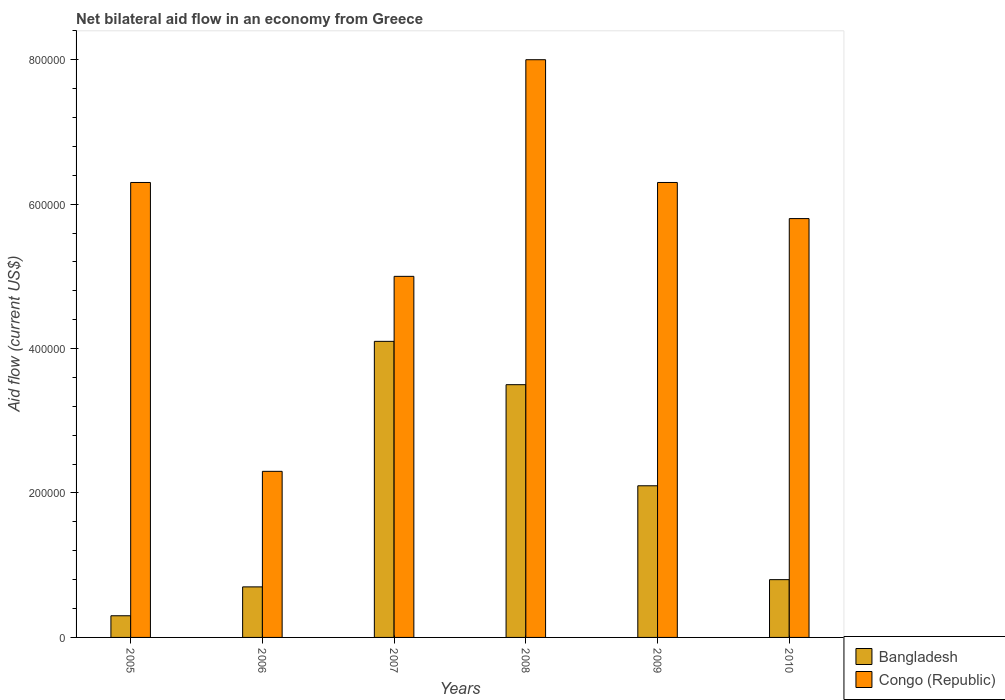How many different coloured bars are there?
Your answer should be very brief. 2. Are the number of bars on each tick of the X-axis equal?
Ensure brevity in your answer.  Yes. How many bars are there on the 6th tick from the right?
Keep it short and to the point. 2. What is the label of the 2nd group of bars from the left?
Your answer should be compact. 2006. What is the net bilateral aid flow in Congo (Republic) in 2009?
Your answer should be compact. 6.30e+05. Across all years, what is the minimum net bilateral aid flow in Congo (Republic)?
Offer a terse response. 2.30e+05. In which year was the net bilateral aid flow in Bangladesh maximum?
Make the answer very short. 2007. What is the total net bilateral aid flow in Congo (Republic) in the graph?
Provide a short and direct response. 3.37e+06. What is the difference between the net bilateral aid flow in Bangladesh in 2005 and that in 2007?
Offer a very short reply. -3.80e+05. What is the average net bilateral aid flow in Bangladesh per year?
Ensure brevity in your answer.  1.92e+05. In the year 2006, what is the difference between the net bilateral aid flow in Congo (Republic) and net bilateral aid flow in Bangladesh?
Your answer should be compact. 1.60e+05. In how many years, is the net bilateral aid flow in Congo (Republic) greater than 480000 US$?
Provide a short and direct response. 5. What is the ratio of the net bilateral aid flow in Congo (Republic) in 2009 to that in 2010?
Give a very brief answer. 1.09. Is the net bilateral aid flow in Bangladesh in 2008 less than that in 2009?
Offer a very short reply. No. Is the difference between the net bilateral aid flow in Congo (Republic) in 2007 and 2009 greater than the difference between the net bilateral aid flow in Bangladesh in 2007 and 2009?
Provide a short and direct response. No. What is the difference between the highest and the second highest net bilateral aid flow in Congo (Republic)?
Offer a very short reply. 1.70e+05. What is the difference between the highest and the lowest net bilateral aid flow in Congo (Republic)?
Your answer should be very brief. 5.70e+05. Is the sum of the net bilateral aid flow in Congo (Republic) in 2008 and 2009 greater than the maximum net bilateral aid flow in Bangladesh across all years?
Your answer should be very brief. Yes. What does the 2nd bar from the left in 2005 represents?
Offer a terse response. Congo (Republic). What does the 1st bar from the right in 2008 represents?
Your answer should be very brief. Congo (Republic). How many bars are there?
Offer a terse response. 12. Are all the bars in the graph horizontal?
Offer a terse response. No. How many years are there in the graph?
Make the answer very short. 6. What is the difference between two consecutive major ticks on the Y-axis?
Your answer should be very brief. 2.00e+05. Where does the legend appear in the graph?
Provide a short and direct response. Bottom right. How many legend labels are there?
Make the answer very short. 2. How are the legend labels stacked?
Ensure brevity in your answer.  Vertical. What is the title of the graph?
Ensure brevity in your answer.  Net bilateral aid flow in an economy from Greece. What is the label or title of the X-axis?
Give a very brief answer. Years. What is the Aid flow (current US$) of Bangladesh in 2005?
Your answer should be compact. 3.00e+04. What is the Aid flow (current US$) in Congo (Republic) in 2005?
Offer a terse response. 6.30e+05. What is the Aid flow (current US$) of Bangladesh in 2006?
Your response must be concise. 7.00e+04. What is the Aid flow (current US$) of Congo (Republic) in 2007?
Your response must be concise. 5.00e+05. What is the Aid flow (current US$) in Bangladesh in 2008?
Make the answer very short. 3.50e+05. What is the Aid flow (current US$) in Congo (Republic) in 2008?
Ensure brevity in your answer.  8.00e+05. What is the Aid flow (current US$) of Bangladesh in 2009?
Provide a succinct answer. 2.10e+05. What is the Aid flow (current US$) of Congo (Republic) in 2009?
Your answer should be very brief. 6.30e+05. What is the Aid flow (current US$) of Congo (Republic) in 2010?
Offer a terse response. 5.80e+05. Across all years, what is the maximum Aid flow (current US$) of Congo (Republic)?
Keep it short and to the point. 8.00e+05. Across all years, what is the minimum Aid flow (current US$) in Bangladesh?
Your response must be concise. 3.00e+04. What is the total Aid flow (current US$) in Bangladesh in the graph?
Offer a terse response. 1.15e+06. What is the total Aid flow (current US$) in Congo (Republic) in the graph?
Provide a short and direct response. 3.37e+06. What is the difference between the Aid flow (current US$) of Bangladesh in 2005 and that in 2006?
Keep it short and to the point. -4.00e+04. What is the difference between the Aid flow (current US$) of Bangladesh in 2005 and that in 2007?
Provide a succinct answer. -3.80e+05. What is the difference between the Aid flow (current US$) in Bangladesh in 2005 and that in 2008?
Provide a succinct answer. -3.20e+05. What is the difference between the Aid flow (current US$) of Congo (Republic) in 2005 and that in 2008?
Your answer should be compact. -1.70e+05. What is the difference between the Aid flow (current US$) in Congo (Republic) in 2005 and that in 2010?
Keep it short and to the point. 5.00e+04. What is the difference between the Aid flow (current US$) in Bangladesh in 2006 and that in 2007?
Ensure brevity in your answer.  -3.40e+05. What is the difference between the Aid flow (current US$) in Bangladesh in 2006 and that in 2008?
Offer a very short reply. -2.80e+05. What is the difference between the Aid flow (current US$) in Congo (Republic) in 2006 and that in 2008?
Give a very brief answer. -5.70e+05. What is the difference between the Aid flow (current US$) of Congo (Republic) in 2006 and that in 2009?
Your response must be concise. -4.00e+05. What is the difference between the Aid flow (current US$) in Bangladesh in 2006 and that in 2010?
Provide a short and direct response. -10000. What is the difference between the Aid flow (current US$) in Congo (Republic) in 2006 and that in 2010?
Your answer should be very brief. -3.50e+05. What is the difference between the Aid flow (current US$) in Congo (Republic) in 2007 and that in 2008?
Make the answer very short. -3.00e+05. What is the difference between the Aid flow (current US$) in Bangladesh in 2007 and that in 2009?
Your response must be concise. 2.00e+05. What is the difference between the Aid flow (current US$) in Congo (Republic) in 2007 and that in 2009?
Your answer should be very brief. -1.30e+05. What is the difference between the Aid flow (current US$) of Congo (Republic) in 2007 and that in 2010?
Offer a terse response. -8.00e+04. What is the difference between the Aid flow (current US$) of Congo (Republic) in 2008 and that in 2009?
Ensure brevity in your answer.  1.70e+05. What is the difference between the Aid flow (current US$) of Congo (Republic) in 2008 and that in 2010?
Ensure brevity in your answer.  2.20e+05. What is the difference between the Aid flow (current US$) in Congo (Republic) in 2009 and that in 2010?
Your response must be concise. 5.00e+04. What is the difference between the Aid flow (current US$) of Bangladesh in 2005 and the Aid flow (current US$) of Congo (Republic) in 2006?
Make the answer very short. -2.00e+05. What is the difference between the Aid flow (current US$) in Bangladesh in 2005 and the Aid flow (current US$) in Congo (Republic) in 2007?
Ensure brevity in your answer.  -4.70e+05. What is the difference between the Aid flow (current US$) in Bangladesh in 2005 and the Aid flow (current US$) in Congo (Republic) in 2008?
Keep it short and to the point. -7.70e+05. What is the difference between the Aid flow (current US$) in Bangladesh in 2005 and the Aid flow (current US$) in Congo (Republic) in 2009?
Your response must be concise. -6.00e+05. What is the difference between the Aid flow (current US$) of Bangladesh in 2005 and the Aid flow (current US$) of Congo (Republic) in 2010?
Offer a terse response. -5.50e+05. What is the difference between the Aid flow (current US$) in Bangladesh in 2006 and the Aid flow (current US$) in Congo (Republic) in 2007?
Give a very brief answer. -4.30e+05. What is the difference between the Aid flow (current US$) of Bangladesh in 2006 and the Aid flow (current US$) of Congo (Republic) in 2008?
Your response must be concise. -7.30e+05. What is the difference between the Aid flow (current US$) of Bangladesh in 2006 and the Aid flow (current US$) of Congo (Republic) in 2009?
Your answer should be very brief. -5.60e+05. What is the difference between the Aid flow (current US$) in Bangladesh in 2006 and the Aid flow (current US$) in Congo (Republic) in 2010?
Your answer should be compact. -5.10e+05. What is the difference between the Aid flow (current US$) in Bangladesh in 2007 and the Aid flow (current US$) in Congo (Republic) in 2008?
Offer a terse response. -3.90e+05. What is the difference between the Aid flow (current US$) in Bangladesh in 2008 and the Aid flow (current US$) in Congo (Republic) in 2009?
Offer a terse response. -2.80e+05. What is the difference between the Aid flow (current US$) in Bangladesh in 2008 and the Aid flow (current US$) in Congo (Republic) in 2010?
Keep it short and to the point. -2.30e+05. What is the difference between the Aid flow (current US$) in Bangladesh in 2009 and the Aid flow (current US$) in Congo (Republic) in 2010?
Keep it short and to the point. -3.70e+05. What is the average Aid flow (current US$) of Bangladesh per year?
Ensure brevity in your answer.  1.92e+05. What is the average Aid flow (current US$) of Congo (Republic) per year?
Ensure brevity in your answer.  5.62e+05. In the year 2005, what is the difference between the Aid flow (current US$) of Bangladesh and Aid flow (current US$) of Congo (Republic)?
Give a very brief answer. -6.00e+05. In the year 2006, what is the difference between the Aid flow (current US$) in Bangladesh and Aid flow (current US$) in Congo (Republic)?
Offer a very short reply. -1.60e+05. In the year 2007, what is the difference between the Aid flow (current US$) in Bangladesh and Aid flow (current US$) in Congo (Republic)?
Make the answer very short. -9.00e+04. In the year 2008, what is the difference between the Aid flow (current US$) in Bangladesh and Aid flow (current US$) in Congo (Republic)?
Ensure brevity in your answer.  -4.50e+05. In the year 2009, what is the difference between the Aid flow (current US$) of Bangladesh and Aid flow (current US$) of Congo (Republic)?
Your answer should be compact. -4.20e+05. In the year 2010, what is the difference between the Aid flow (current US$) of Bangladesh and Aid flow (current US$) of Congo (Republic)?
Keep it short and to the point. -5.00e+05. What is the ratio of the Aid flow (current US$) of Bangladesh in 2005 to that in 2006?
Offer a terse response. 0.43. What is the ratio of the Aid flow (current US$) in Congo (Republic) in 2005 to that in 2006?
Make the answer very short. 2.74. What is the ratio of the Aid flow (current US$) in Bangladesh in 2005 to that in 2007?
Your answer should be very brief. 0.07. What is the ratio of the Aid flow (current US$) in Congo (Republic) in 2005 to that in 2007?
Your response must be concise. 1.26. What is the ratio of the Aid flow (current US$) in Bangladesh in 2005 to that in 2008?
Offer a very short reply. 0.09. What is the ratio of the Aid flow (current US$) in Congo (Republic) in 2005 to that in 2008?
Give a very brief answer. 0.79. What is the ratio of the Aid flow (current US$) in Bangladesh in 2005 to that in 2009?
Offer a very short reply. 0.14. What is the ratio of the Aid flow (current US$) of Congo (Republic) in 2005 to that in 2009?
Offer a terse response. 1. What is the ratio of the Aid flow (current US$) in Congo (Republic) in 2005 to that in 2010?
Ensure brevity in your answer.  1.09. What is the ratio of the Aid flow (current US$) of Bangladesh in 2006 to that in 2007?
Your answer should be compact. 0.17. What is the ratio of the Aid flow (current US$) in Congo (Republic) in 2006 to that in 2007?
Give a very brief answer. 0.46. What is the ratio of the Aid flow (current US$) in Congo (Republic) in 2006 to that in 2008?
Provide a succinct answer. 0.29. What is the ratio of the Aid flow (current US$) of Bangladesh in 2006 to that in 2009?
Provide a short and direct response. 0.33. What is the ratio of the Aid flow (current US$) in Congo (Republic) in 2006 to that in 2009?
Provide a succinct answer. 0.37. What is the ratio of the Aid flow (current US$) in Bangladesh in 2006 to that in 2010?
Ensure brevity in your answer.  0.88. What is the ratio of the Aid flow (current US$) in Congo (Republic) in 2006 to that in 2010?
Keep it short and to the point. 0.4. What is the ratio of the Aid flow (current US$) of Bangladesh in 2007 to that in 2008?
Your response must be concise. 1.17. What is the ratio of the Aid flow (current US$) in Bangladesh in 2007 to that in 2009?
Your answer should be very brief. 1.95. What is the ratio of the Aid flow (current US$) in Congo (Republic) in 2007 to that in 2009?
Give a very brief answer. 0.79. What is the ratio of the Aid flow (current US$) in Bangladesh in 2007 to that in 2010?
Offer a very short reply. 5.12. What is the ratio of the Aid flow (current US$) in Congo (Republic) in 2007 to that in 2010?
Offer a very short reply. 0.86. What is the ratio of the Aid flow (current US$) in Bangladesh in 2008 to that in 2009?
Offer a very short reply. 1.67. What is the ratio of the Aid flow (current US$) in Congo (Republic) in 2008 to that in 2009?
Provide a succinct answer. 1.27. What is the ratio of the Aid flow (current US$) of Bangladesh in 2008 to that in 2010?
Your response must be concise. 4.38. What is the ratio of the Aid flow (current US$) in Congo (Republic) in 2008 to that in 2010?
Your answer should be compact. 1.38. What is the ratio of the Aid flow (current US$) in Bangladesh in 2009 to that in 2010?
Give a very brief answer. 2.62. What is the ratio of the Aid flow (current US$) of Congo (Republic) in 2009 to that in 2010?
Ensure brevity in your answer.  1.09. What is the difference between the highest and the second highest Aid flow (current US$) of Bangladesh?
Provide a succinct answer. 6.00e+04. What is the difference between the highest and the second highest Aid flow (current US$) in Congo (Republic)?
Ensure brevity in your answer.  1.70e+05. What is the difference between the highest and the lowest Aid flow (current US$) in Congo (Republic)?
Offer a very short reply. 5.70e+05. 